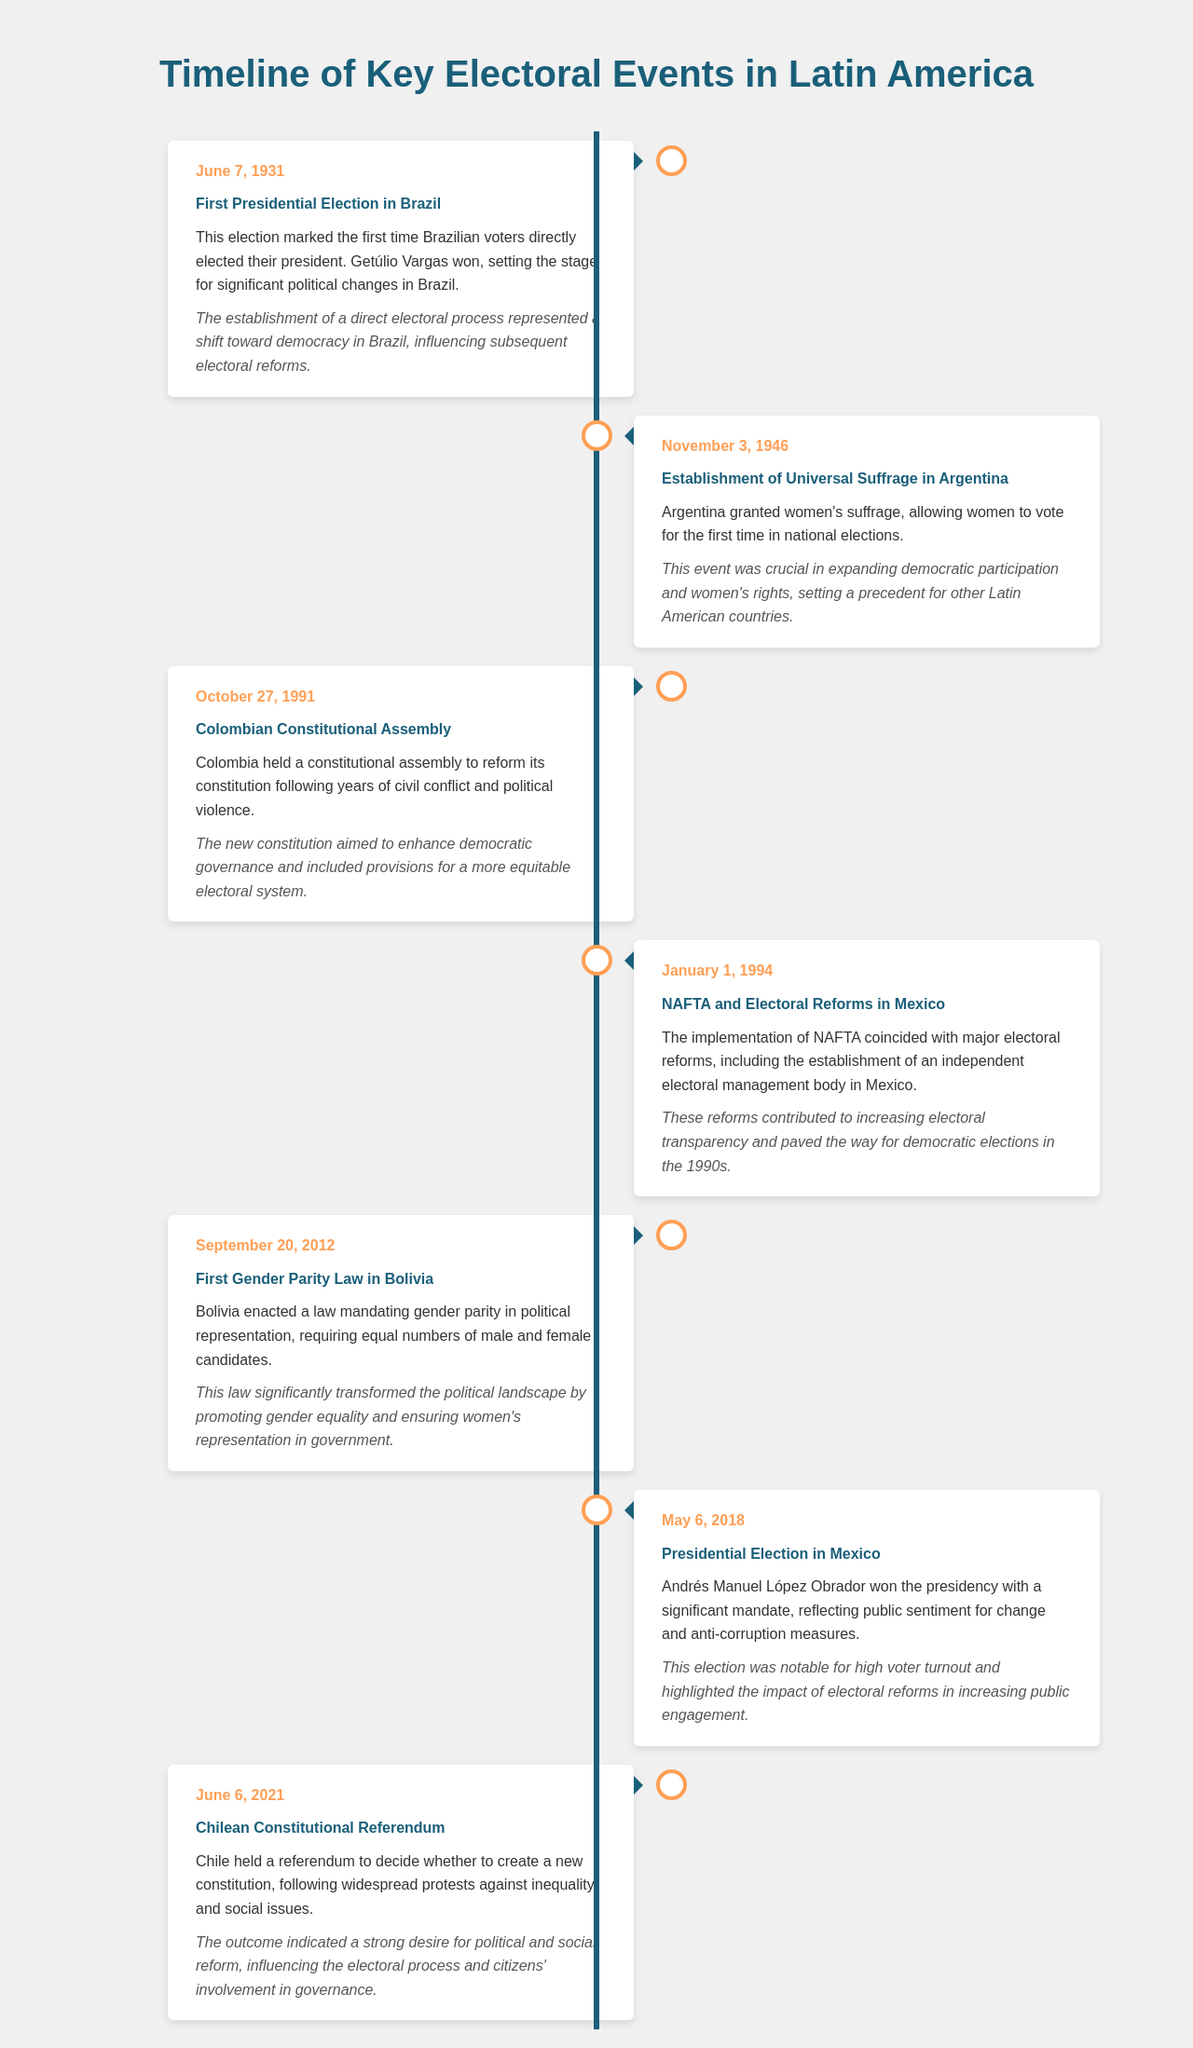what significant electoral event occurred in Brazil on June 7, 1931? The event marked the first time Brazilian voters directly elected their president.
Answer: First Presidential Election which country established universal suffrage for women on November 3, 1946? The event allowed women to vote in national elections.
Answer: Argentina what was the date of the Colombian Constitutional Assembly? This assembly was held to reform the constitution after years of civil conflict.
Answer: October 27, 1991 what major reform took place in Mexico coinciding with NAFTA on January 1, 1994? The establishment of an independent electoral management body.
Answer: Electoral reforms what law was enacted in Bolivia on September 20, 2012? This law mandated gender parity in political representation.
Answer: Gender Parity Law what was notable about the presidential election in Mexico on May 6, 2018? Andrés Manuel López Obrador won with a significant mandate, reflecting public sentiment for change.
Answer: High voter turnout what event did Chile hold on June 6, 2021? The referendum was to decide whether to create a new constitution.
Answer: Constitutional Referendum what was a key focus of the constitutional reform in Colombia following the Constitutional Assembly? The new constitution aimed to enhance democratic governance.
Answer: Democratic governance which electoral event in Argentina was significant for women's rights? This event was crucial in expanding democratic participation and women's rights.
Answer: Establishment of Universal Suffrage 